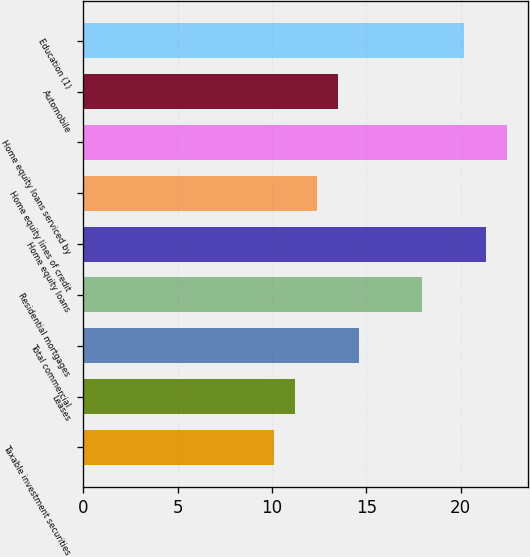<chart> <loc_0><loc_0><loc_500><loc_500><bar_chart><fcel>Taxable investment securities<fcel>Leases<fcel>Total commercial<fcel>Residential mortgages<fcel>Home equity loans<fcel>Home equity lines of credit<fcel>Home equity loans serviced by<fcel>Automobile<fcel>Education (1)<nl><fcel>10.12<fcel>11.24<fcel>14.6<fcel>17.96<fcel>21.32<fcel>12.36<fcel>22.44<fcel>13.48<fcel>20.2<nl></chart> 